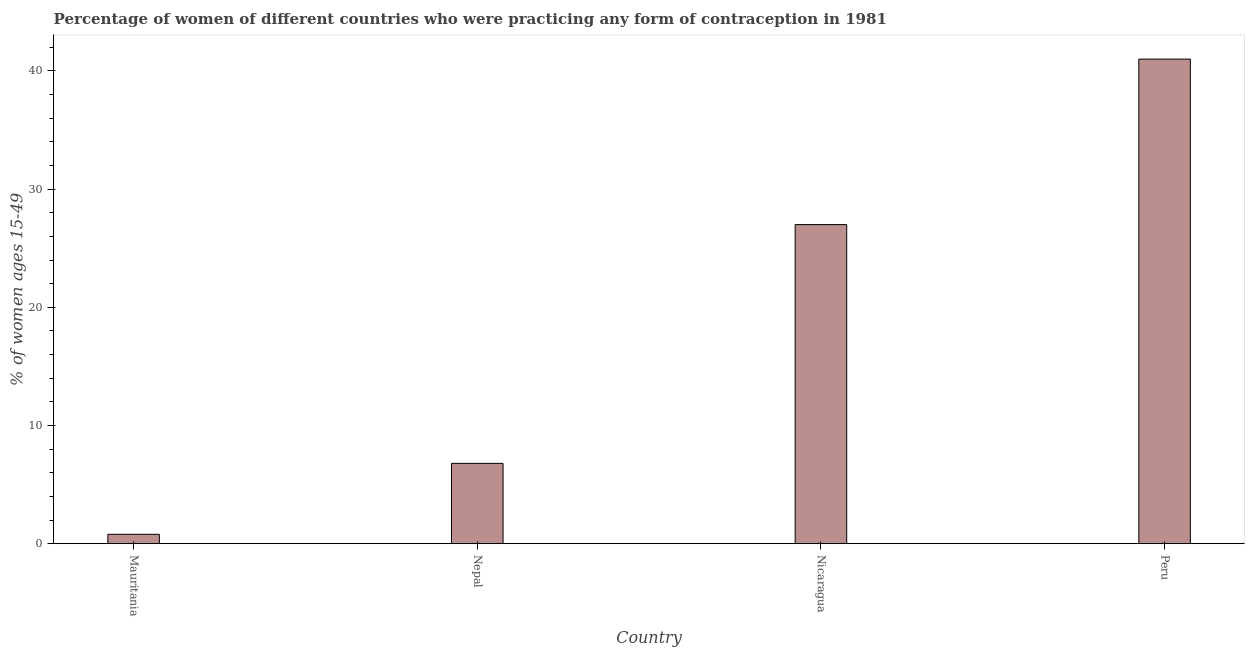Does the graph contain any zero values?
Offer a very short reply. No. What is the title of the graph?
Keep it short and to the point. Percentage of women of different countries who were practicing any form of contraception in 1981. What is the label or title of the X-axis?
Give a very brief answer. Country. What is the label or title of the Y-axis?
Provide a succinct answer. % of women ages 15-49. Across all countries, what is the maximum contraceptive prevalence?
Make the answer very short. 41. In which country was the contraceptive prevalence maximum?
Give a very brief answer. Peru. In which country was the contraceptive prevalence minimum?
Your response must be concise. Mauritania. What is the sum of the contraceptive prevalence?
Provide a short and direct response. 75.6. What is the ratio of the contraceptive prevalence in Mauritania to that in Nepal?
Offer a terse response. 0.12. What is the difference between the highest and the second highest contraceptive prevalence?
Your response must be concise. 14. What is the difference between the highest and the lowest contraceptive prevalence?
Keep it short and to the point. 40.2. In how many countries, is the contraceptive prevalence greater than the average contraceptive prevalence taken over all countries?
Offer a very short reply. 2. How many countries are there in the graph?
Ensure brevity in your answer.  4. What is the % of women ages 15-49 in Nepal?
Offer a very short reply. 6.8. What is the difference between the % of women ages 15-49 in Mauritania and Nepal?
Provide a short and direct response. -6. What is the difference between the % of women ages 15-49 in Mauritania and Nicaragua?
Give a very brief answer. -26.2. What is the difference between the % of women ages 15-49 in Mauritania and Peru?
Offer a terse response. -40.2. What is the difference between the % of women ages 15-49 in Nepal and Nicaragua?
Your answer should be compact. -20.2. What is the difference between the % of women ages 15-49 in Nepal and Peru?
Offer a terse response. -34.2. What is the difference between the % of women ages 15-49 in Nicaragua and Peru?
Ensure brevity in your answer.  -14. What is the ratio of the % of women ages 15-49 in Mauritania to that in Nepal?
Provide a succinct answer. 0.12. What is the ratio of the % of women ages 15-49 in Mauritania to that in Peru?
Make the answer very short. 0.02. What is the ratio of the % of women ages 15-49 in Nepal to that in Nicaragua?
Keep it short and to the point. 0.25. What is the ratio of the % of women ages 15-49 in Nepal to that in Peru?
Ensure brevity in your answer.  0.17. What is the ratio of the % of women ages 15-49 in Nicaragua to that in Peru?
Your response must be concise. 0.66. 